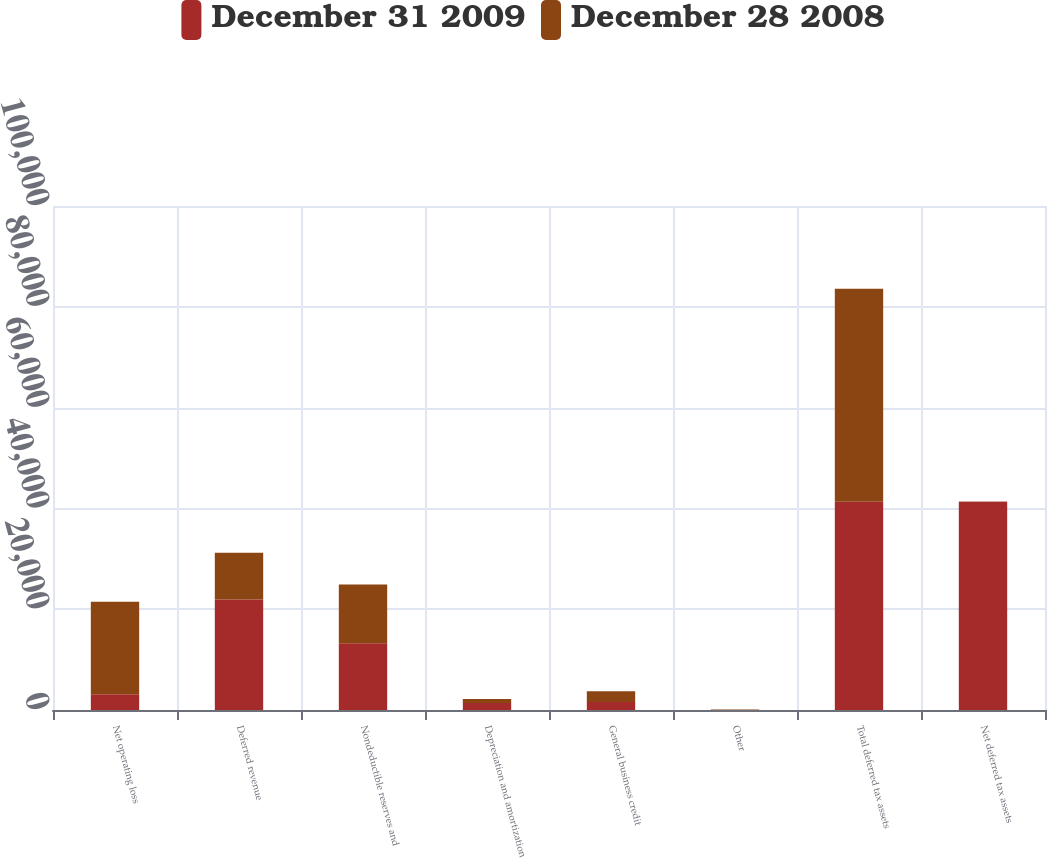Convert chart to OTSL. <chart><loc_0><loc_0><loc_500><loc_500><stacked_bar_chart><ecel><fcel>Net operating loss<fcel>Deferred revenue<fcel>Nondeductible reserves and<fcel>Depreciation and amortization<fcel>General business credit<fcel>Other<fcel>Total deferred tax assets<fcel>Net deferred tax assets<nl><fcel>December 31 2009<fcel>3144<fcel>21915<fcel>13262<fcel>1412<fcel>1574<fcel>16<fcel>41323<fcel>41323<nl><fcel>December 28 2008<fcel>18327<fcel>9276<fcel>11651<fcel>768<fcel>2137<fcel>101<fcel>42260<fcel>69<nl></chart> 